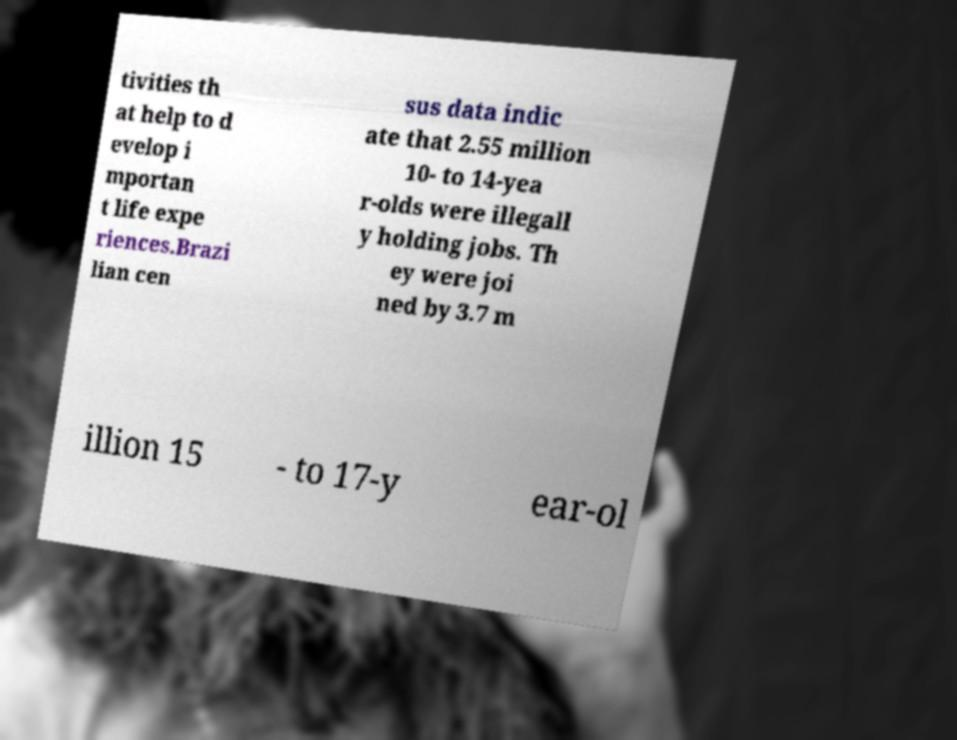Please identify and transcribe the text found in this image. tivities th at help to d evelop i mportan t life expe riences.Brazi lian cen sus data indic ate that 2.55 million 10- to 14-yea r-olds were illegall y holding jobs. Th ey were joi ned by 3.7 m illion 15 - to 17-y ear-ol 